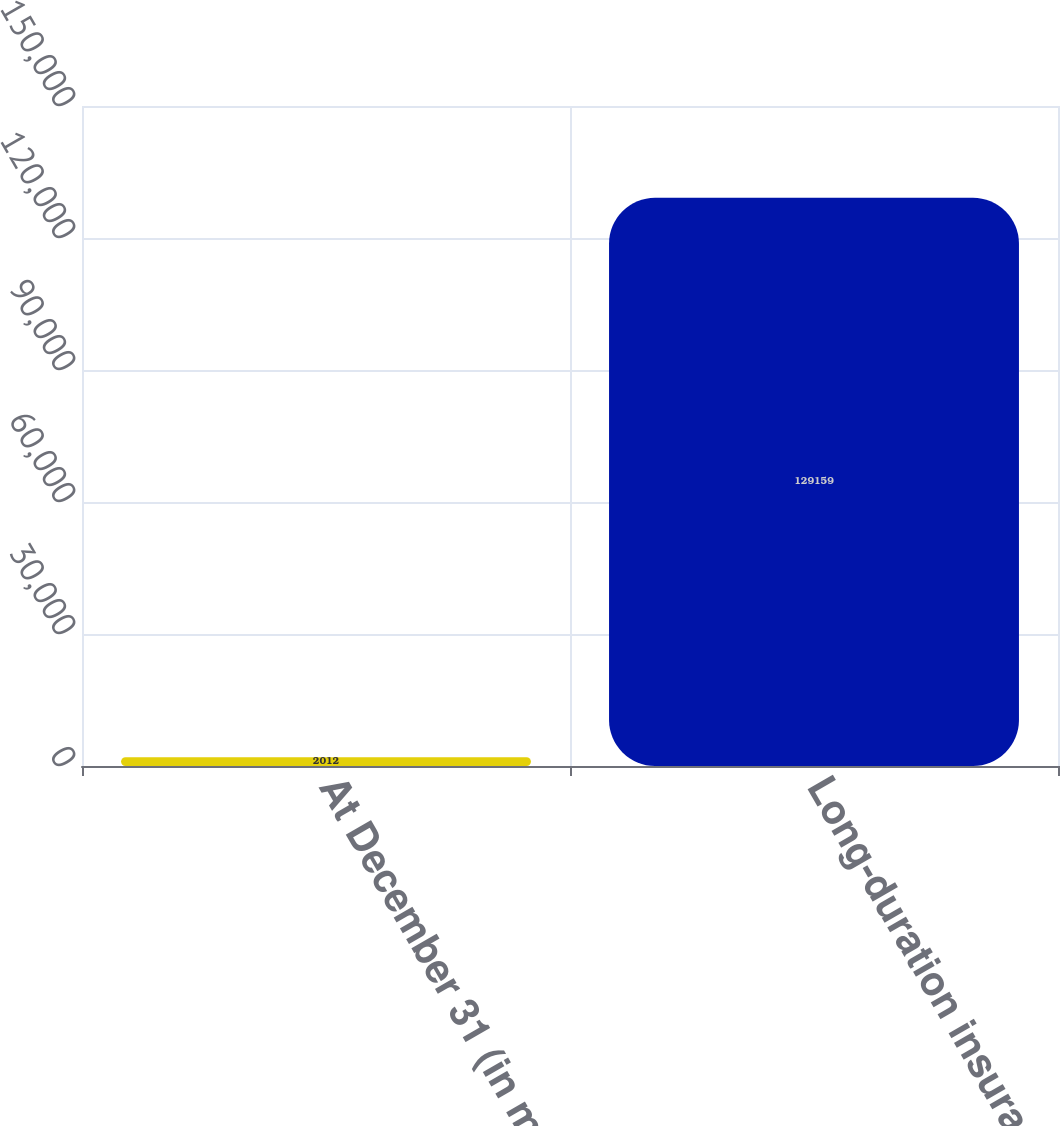Convert chart to OTSL. <chart><loc_0><loc_0><loc_500><loc_500><bar_chart><fcel>At December 31 (in millions)<fcel>Long-duration insurance in<nl><fcel>2012<fcel>129159<nl></chart> 